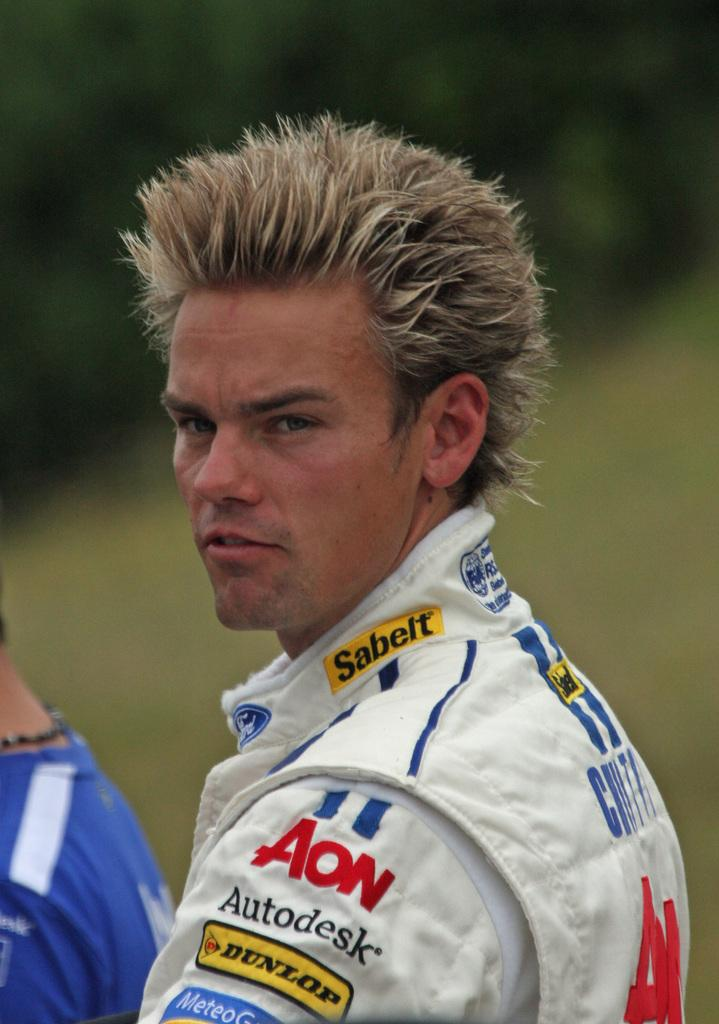Who or what is the main subject of the image? There is a person in the image. What is the person wearing? The person is wearing a white dress. What can be seen in the background of the image? The background of the image is green. How many wrens can be seen in the image? There are no wrens present in the image. What type of lizards are crawling on the person's dress in the image? There are no lizards present in the image. 